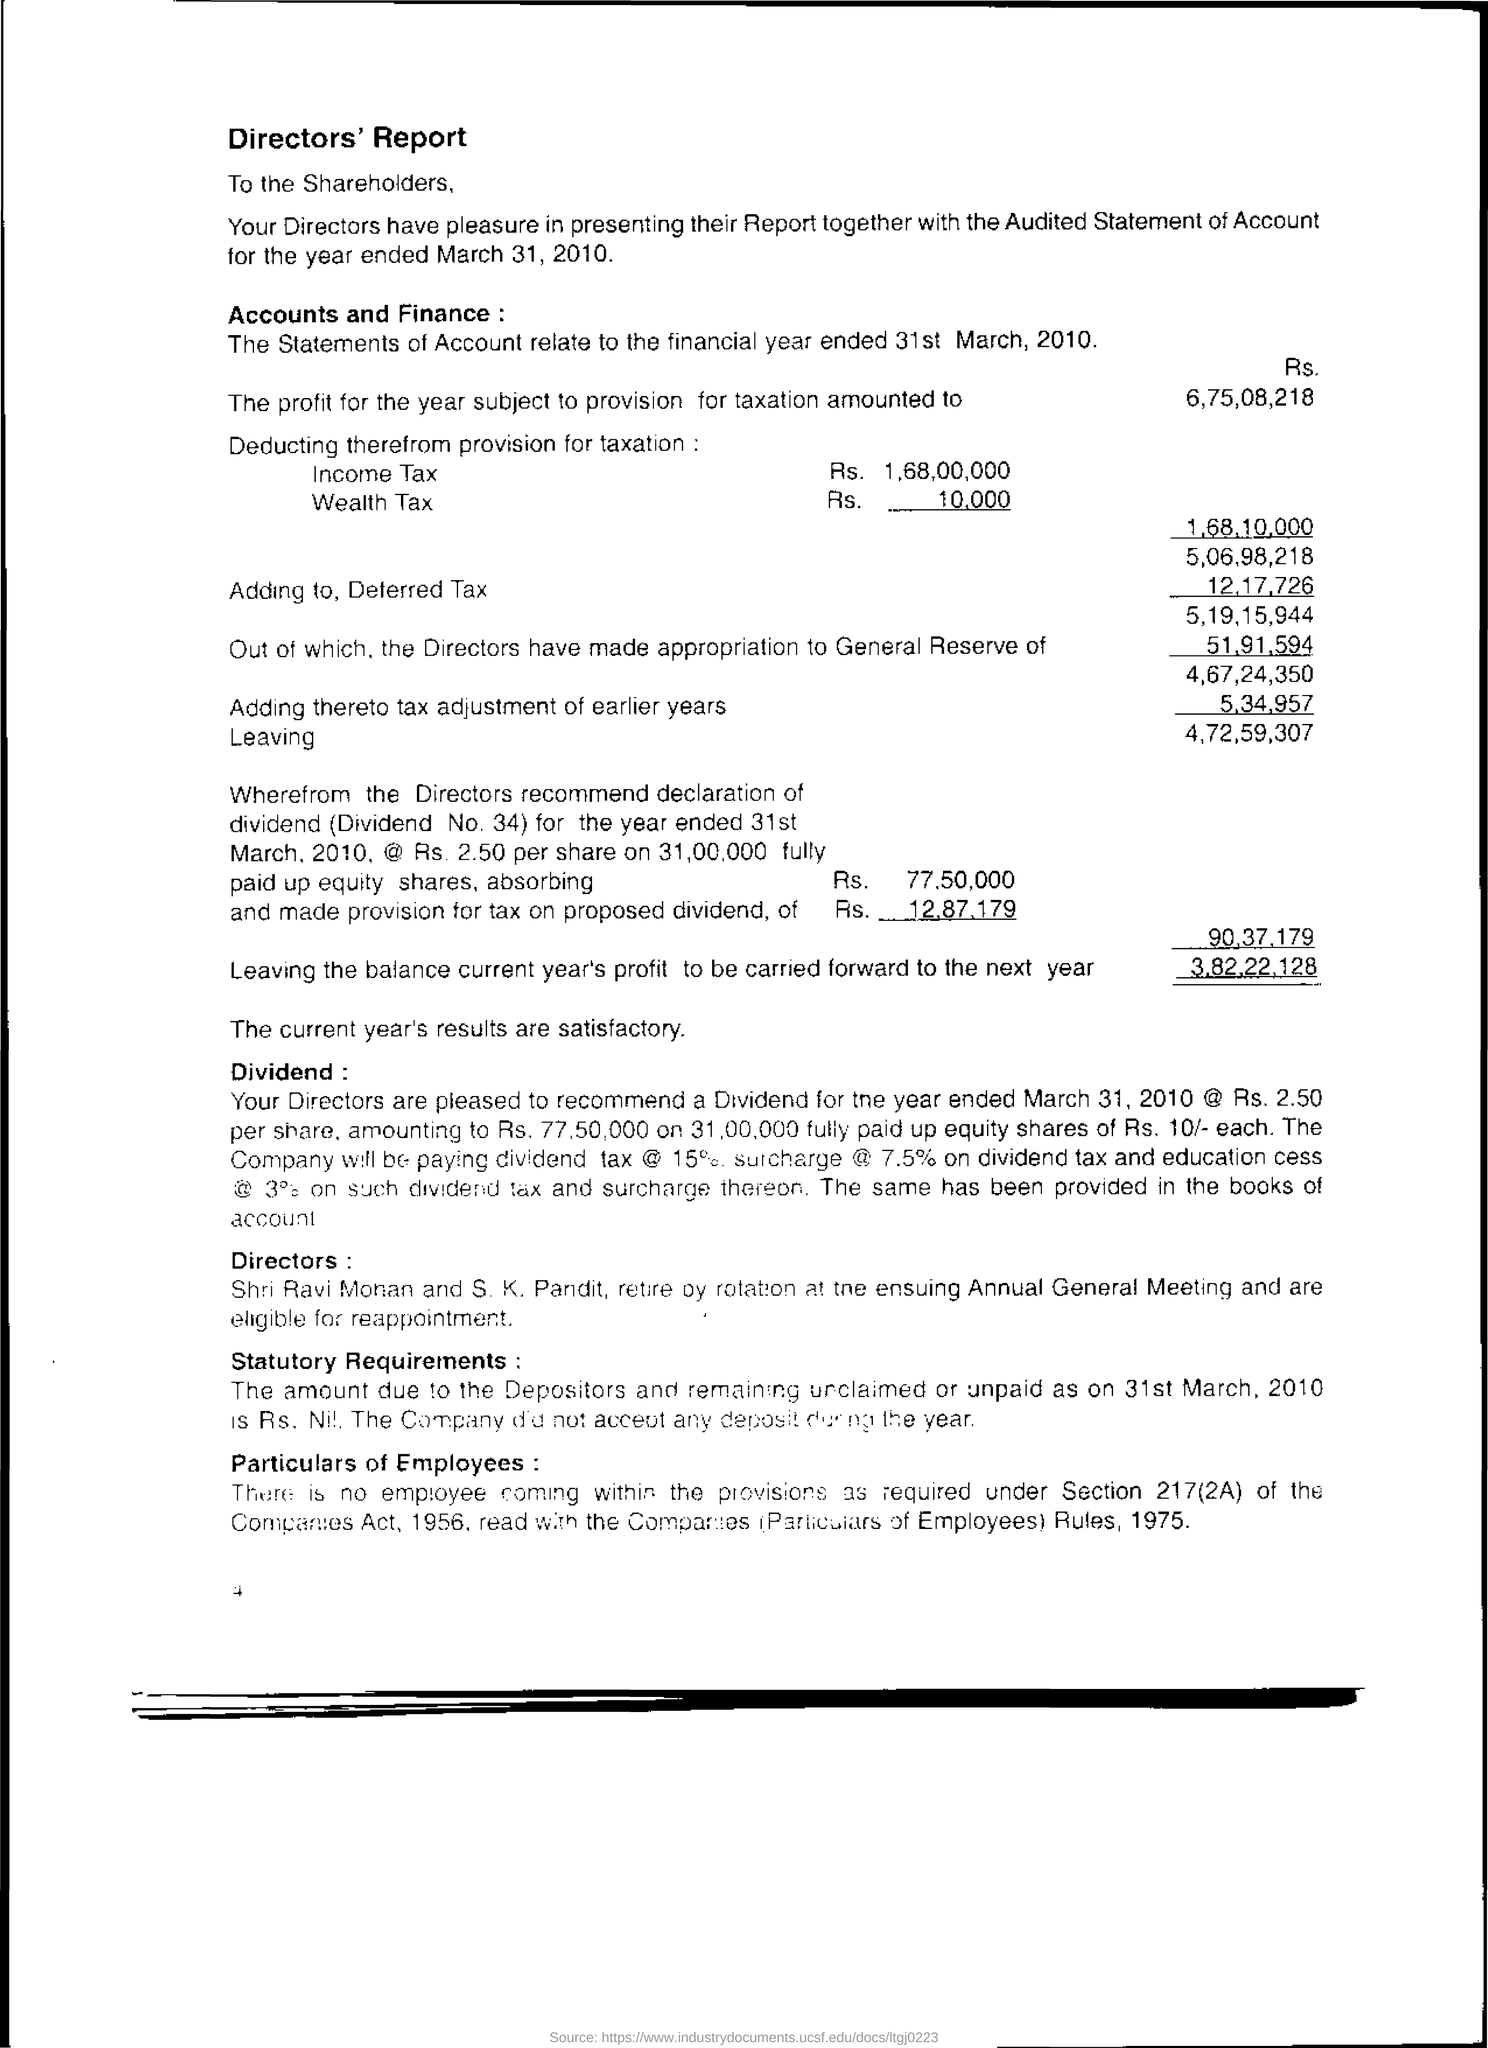Whom do the Directors sent the report?
Ensure brevity in your answer.  Shareholders. 